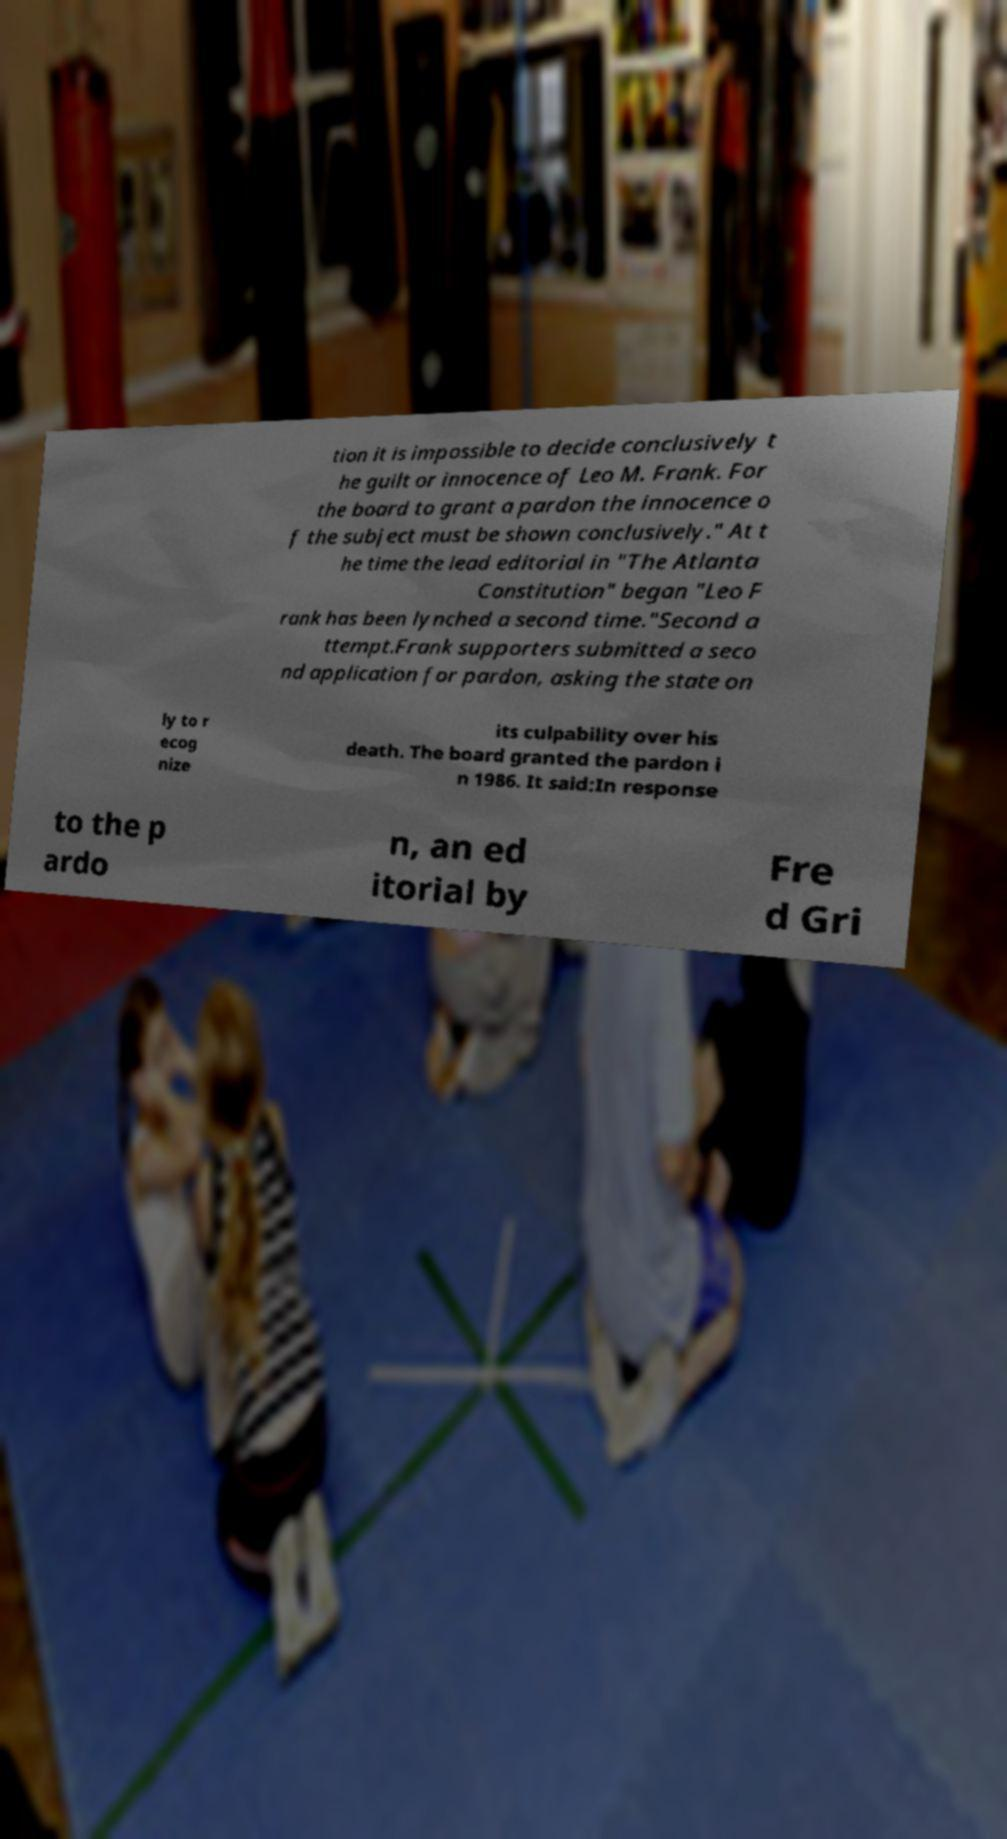Could you extract and type out the text from this image? tion it is impossible to decide conclusively t he guilt or innocence of Leo M. Frank. For the board to grant a pardon the innocence o f the subject must be shown conclusively." At t he time the lead editorial in "The Atlanta Constitution" began "Leo F rank has been lynched a second time."Second a ttempt.Frank supporters submitted a seco nd application for pardon, asking the state on ly to r ecog nize its culpability over his death. The board granted the pardon i n 1986. It said:In response to the p ardo n, an ed itorial by Fre d Gri 